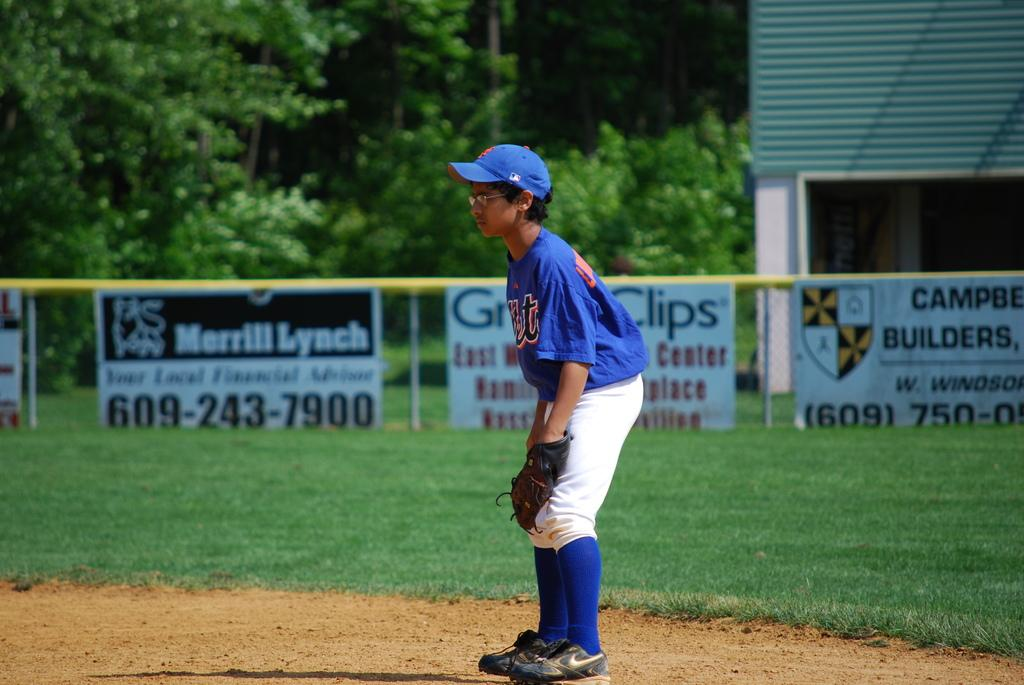<image>
Create a compact narrative representing the image presented. A boy in a blue baseball uniform stands in front an ad for Merrill Lynch. 